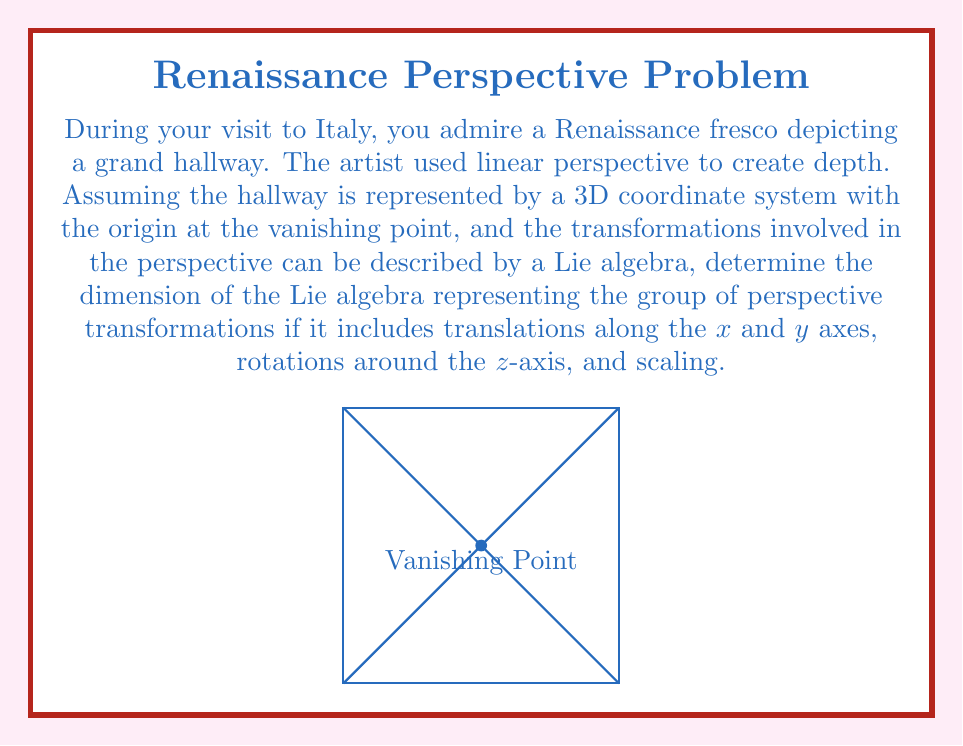Show me your answer to this math problem. To solve this problem, let's break it down step-by-step:

1) First, let's identify the transformations involved:
   - Translations along x-axis
   - Translations along y-axis
   - Rotations around z-axis
   - Scaling

2) In Lie algebra theory, each independent transformation corresponds to a generator of the algebra. The dimension of the Lie algebra is equal to the number of independent generators.

3) Let's analyze each transformation:
   - Translation along x-axis: 1 generator
   - Translation along y-axis: 1 generator
   - Rotation around z-axis: 1 generator
   - Scaling: 1 generator

4) The generators for these transformations can be represented as matrices:
   - X-translation: $T_x = \begin{pmatrix} 0 & 0 & 1 \\ 0 & 0 & 0 \\ 0 & 0 & 0 \end{pmatrix}$
   - Y-translation: $T_y = \begin{pmatrix} 0 & 0 & 0 \\ 0 & 0 & 1 \\ 0 & 0 & 0 \end{pmatrix}$
   - Z-rotation: $R_z = \begin{pmatrix} 0 & -1 & 0 \\ 1 & 0 & 0 \\ 0 & 0 & 0 \end{pmatrix}$
   - Scaling: $S = \begin{pmatrix} 1 & 0 & 0 \\ 0 & 1 & 0 \\ 0 & 0 & 0 \end{pmatrix}$

5) Each of these generators is linearly independent, meaning they cannot be expressed as a linear combination of the others.

6) The dimension of a Lie algebra is equal to the number of linearly independent generators.

Therefore, the dimension of the Lie algebra representing the group of perspective transformations in this case is 4.
Answer: 4 